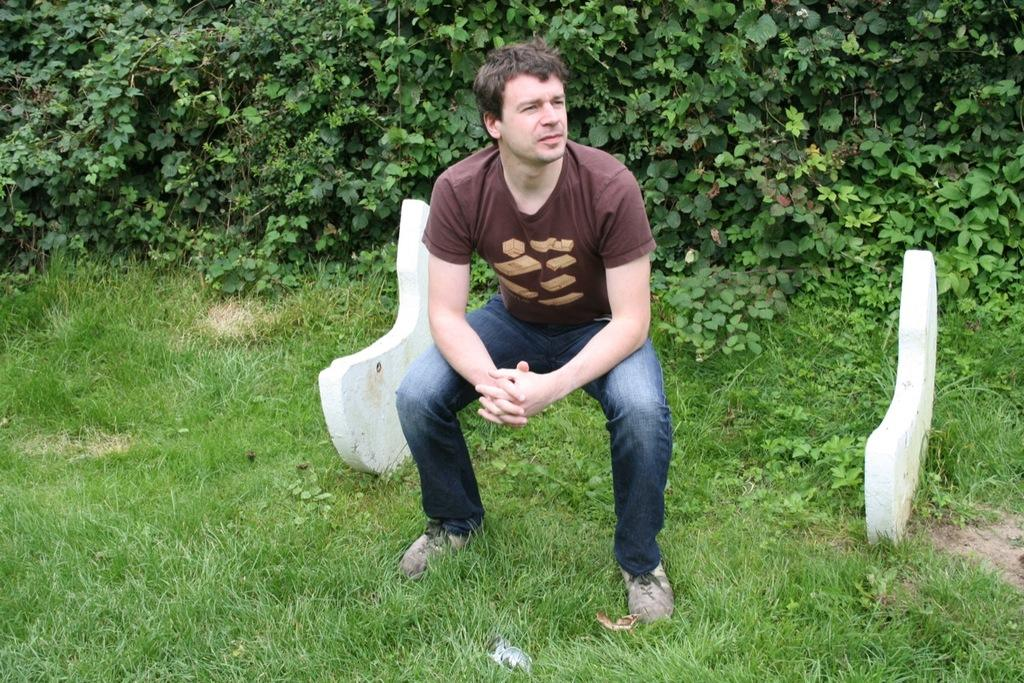Who is present in the image? There is a man in the image. What type of clothing is the man wearing on his upper body? The man is wearing a t-shirt. What type of clothing is the man wearing on his lower body? The man is wearing trousers. What type of vegetation can be seen behind the man? There are trees visible behind the man. What type of ground surface is visible at the bottom of the image? There is grass at the bottom of the image. What type of coat is the man wearing on the bed in the image? There is no coat or bed present in the image; the man is wearing a t-shirt and trousers. What type of pot is visible on the grass in the image? There is no pot visible on the grass in the image; there is only grass at the bottom of the image. 